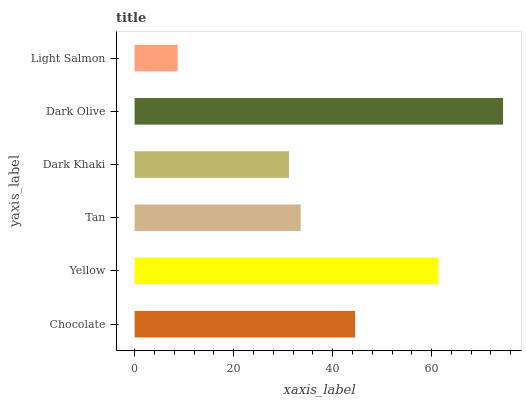Is Light Salmon the minimum?
Answer yes or no. Yes. Is Dark Olive the maximum?
Answer yes or no. Yes. Is Yellow the minimum?
Answer yes or no. No. Is Yellow the maximum?
Answer yes or no. No. Is Yellow greater than Chocolate?
Answer yes or no. Yes. Is Chocolate less than Yellow?
Answer yes or no. Yes. Is Chocolate greater than Yellow?
Answer yes or no. No. Is Yellow less than Chocolate?
Answer yes or no. No. Is Chocolate the high median?
Answer yes or no. Yes. Is Tan the low median?
Answer yes or no. Yes. Is Dark Khaki the high median?
Answer yes or no. No. Is Chocolate the low median?
Answer yes or no. No. 